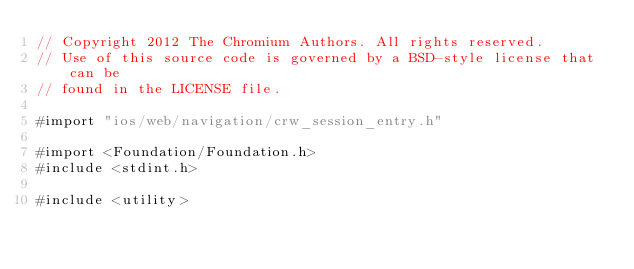<code> <loc_0><loc_0><loc_500><loc_500><_ObjectiveC_>// Copyright 2012 The Chromium Authors. All rights reserved.
// Use of this source code is governed by a BSD-style license that can be
// found in the LICENSE file.

#import "ios/web/navigation/crw_session_entry.h"

#import <Foundation/Foundation.h>
#include <stdint.h>

#include <utility>
</code> 